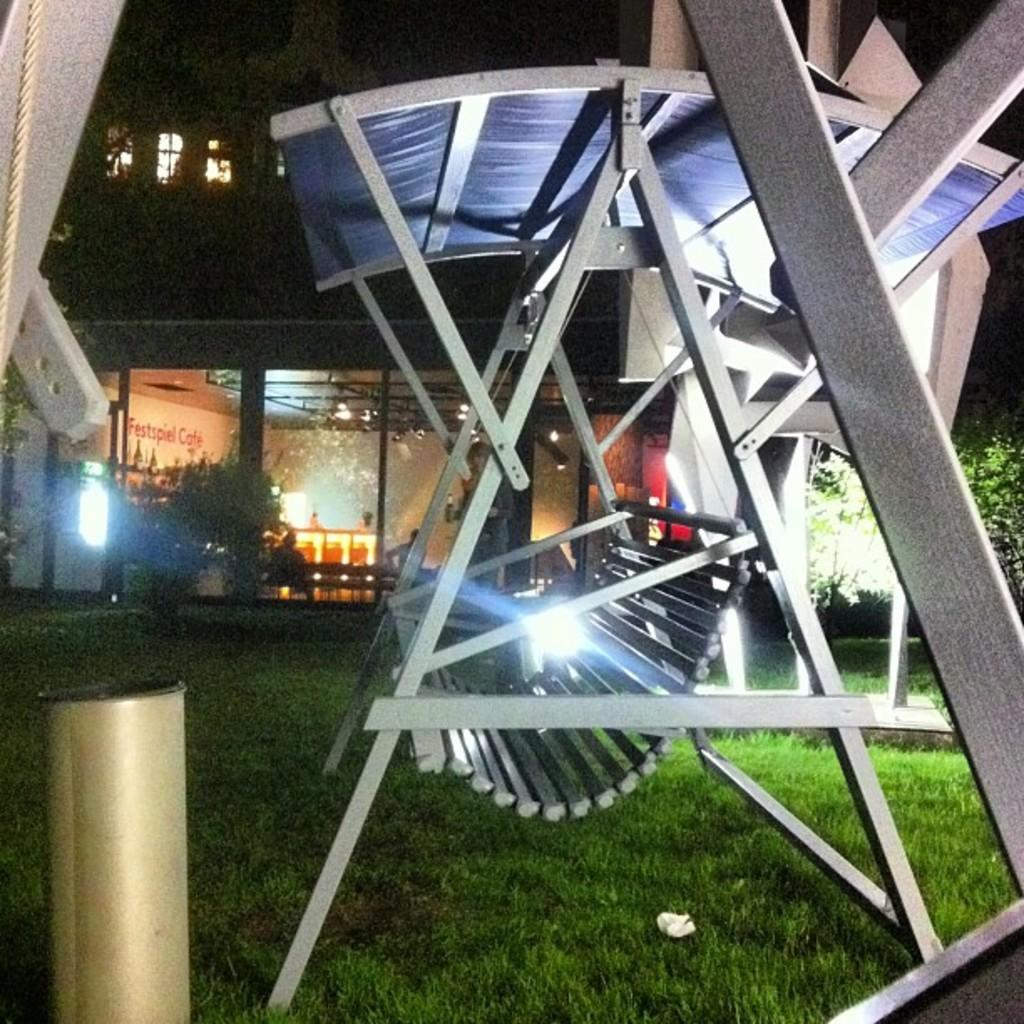What is located on the grass in the image? There is a garden swing on the grass. What type of vegetation can be seen in the image? There are trees in the image. What kind of building is present in the image? There is a building with glass walls in the image. What type of beef is being served at the barbecue in the image? There is no barbecue or beef present in the image. What hobbies are the people in the image engaged in? The image does not show any people, so their hobbies cannot be determined. 